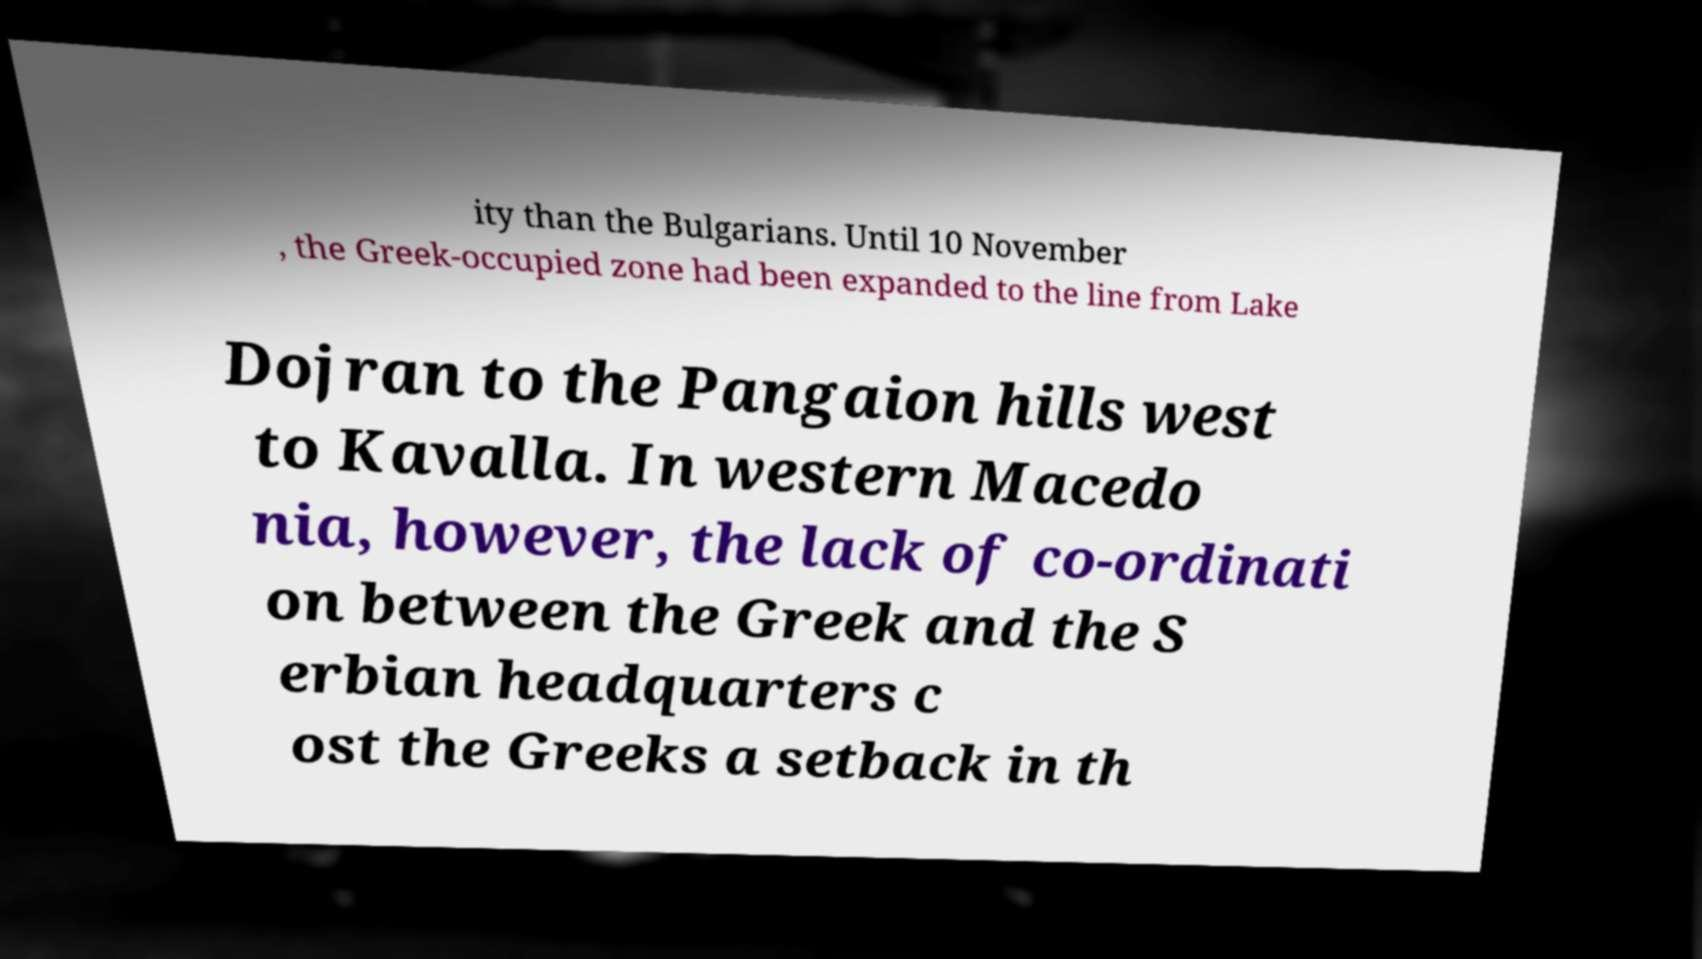For documentation purposes, I need the text within this image transcribed. Could you provide that? ity than the Bulgarians. Until 10 November , the Greek-occupied zone had been expanded to the line from Lake Dojran to the Pangaion hills west to Kavalla. In western Macedo nia, however, the lack of co-ordinati on between the Greek and the S erbian headquarters c ost the Greeks a setback in th 